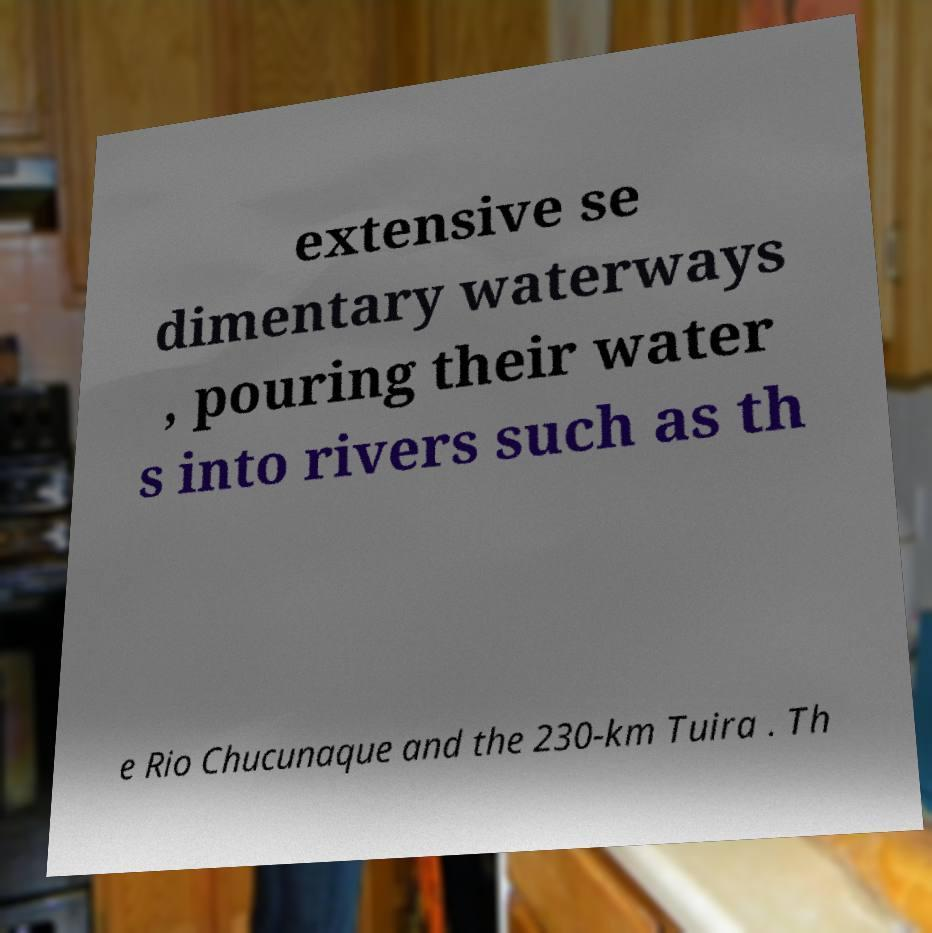For documentation purposes, I need the text within this image transcribed. Could you provide that? extensive se dimentary waterways , pouring their water s into rivers such as th e Rio Chucunaque and the 230-km Tuira . Th 